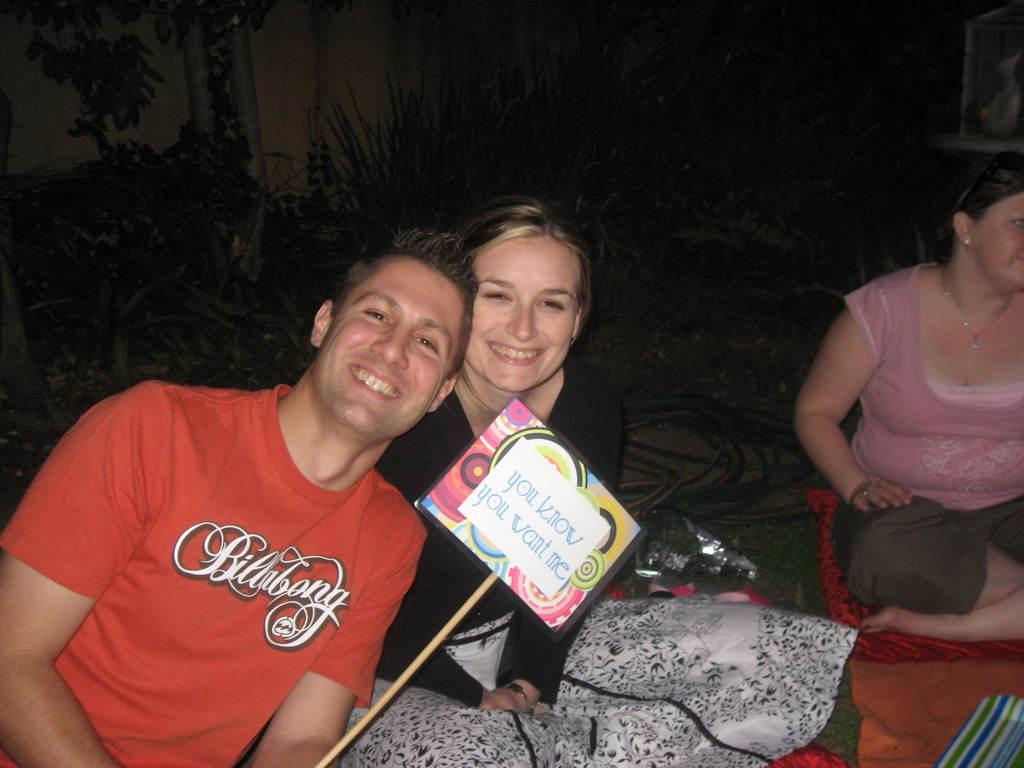Can you describe this image briefly? In this image I can see three persons. In front the person is wearing red color shirt and holding the board and the board is in multi color and I can see the dark background. 